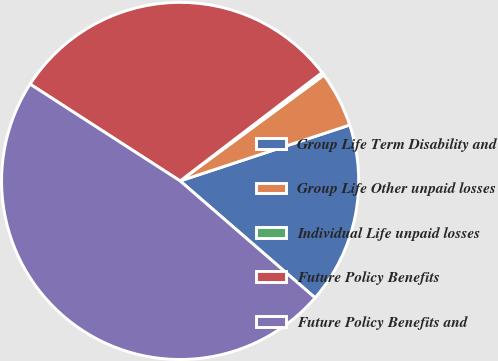Convert chart. <chart><loc_0><loc_0><loc_500><loc_500><pie_chart><fcel>Group Life Term Disability and<fcel>Group Life Other unpaid losses<fcel>Individual Life unpaid losses<fcel>Future Policy Benefits<fcel>Future Policy Benefits and<nl><fcel>16.43%<fcel>5.03%<fcel>0.28%<fcel>30.5%<fcel>47.76%<nl></chart> 